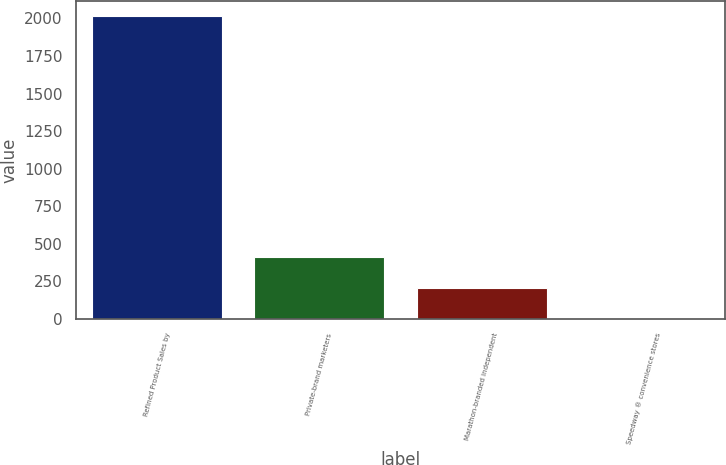Convert chart to OTSL. <chart><loc_0><loc_0><loc_500><loc_500><bar_chart><fcel>Refined Product Sales by<fcel>Private-brand marketers<fcel>Marathon-branded independent<fcel>Speedway ® convenience stores<nl><fcel>2013<fcel>409.8<fcel>209.4<fcel>9<nl></chart> 